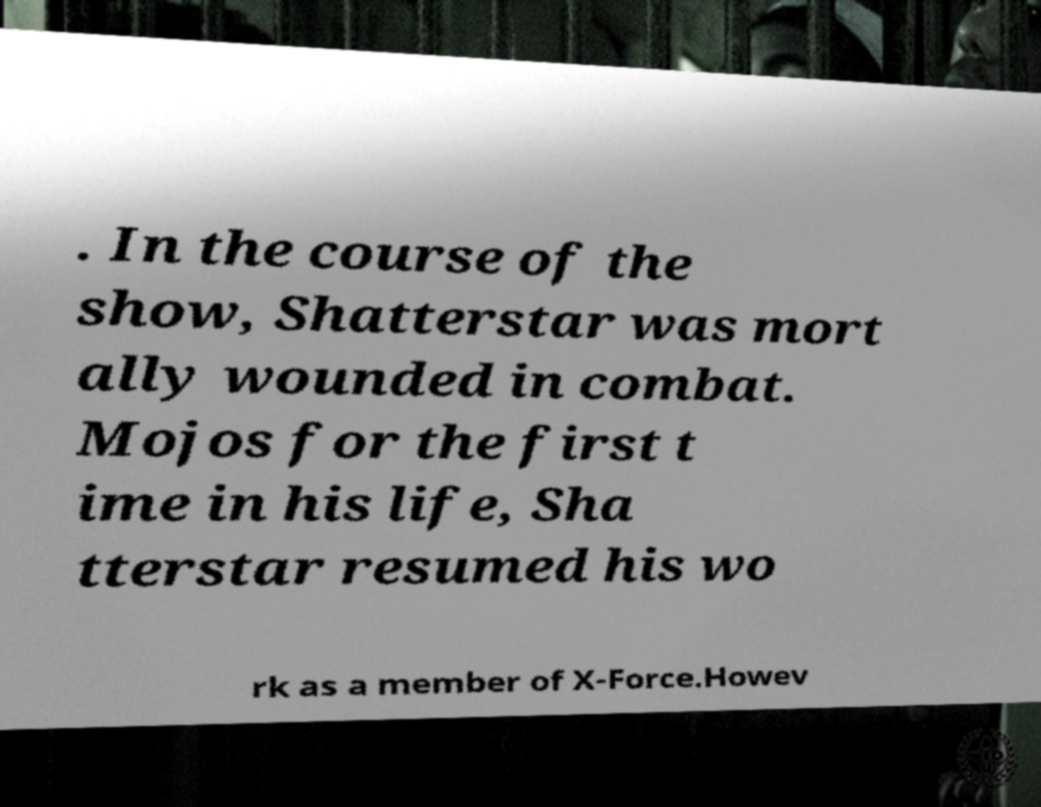Please read and relay the text visible in this image. What does it say? . In the course of the show, Shatterstar was mort ally wounded in combat. Mojos for the first t ime in his life, Sha tterstar resumed his wo rk as a member of X-Force.Howev 